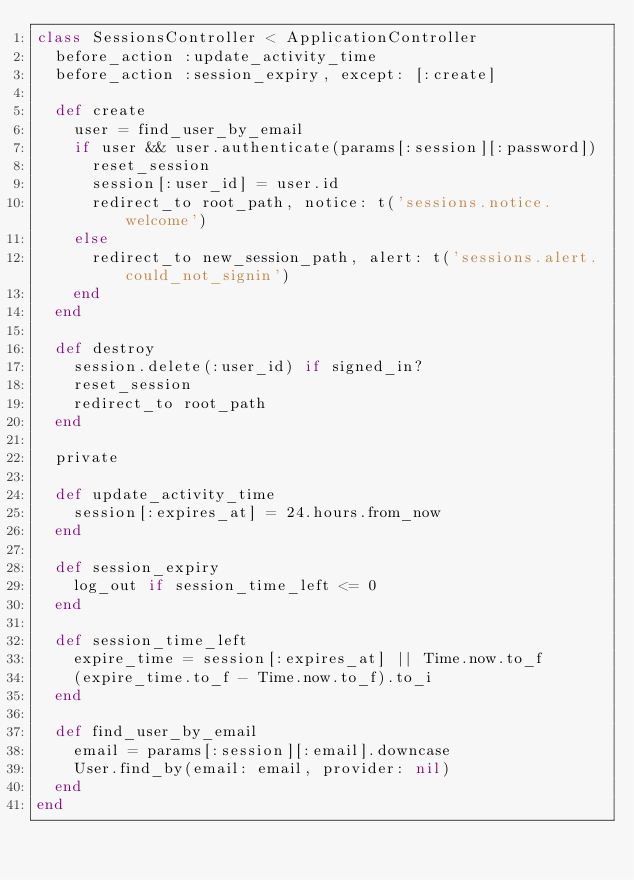<code> <loc_0><loc_0><loc_500><loc_500><_Ruby_>class SessionsController < ApplicationController
  before_action :update_activity_time
  before_action :session_expiry, except: [:create]

  def create
    user = find_user_by_email
    if user && user.authenticate(params[:session][:password])
      reset_session
      session[:user_id] = user.id
      redirect_to root_path, notice: t('sessions.notice.welcome')
    else
      redirect_to new_session_path, alert: t('sessions.alert.could_not_signin')
    end
  end

  def destroy
    session.delete(:user_id) if signed_in?
    reset_session
    redirect_to root_path
  end

  private

  def update_activity_time
    session[:expires_at] = 24.hours.from_now
  end

  def session_expiry
    log_out if session_time_left <= 0
  end

  def session_time_left
    expire_time = session[:expires_at] || Time.now.to_f
    (expire_time.to_f - Time.now.to_f).to_i
  end

  def find_user_by_email
    email = params[:session][:email].downcase
    User.find_by(email: email, provider: nil)
  end
end
</code> 